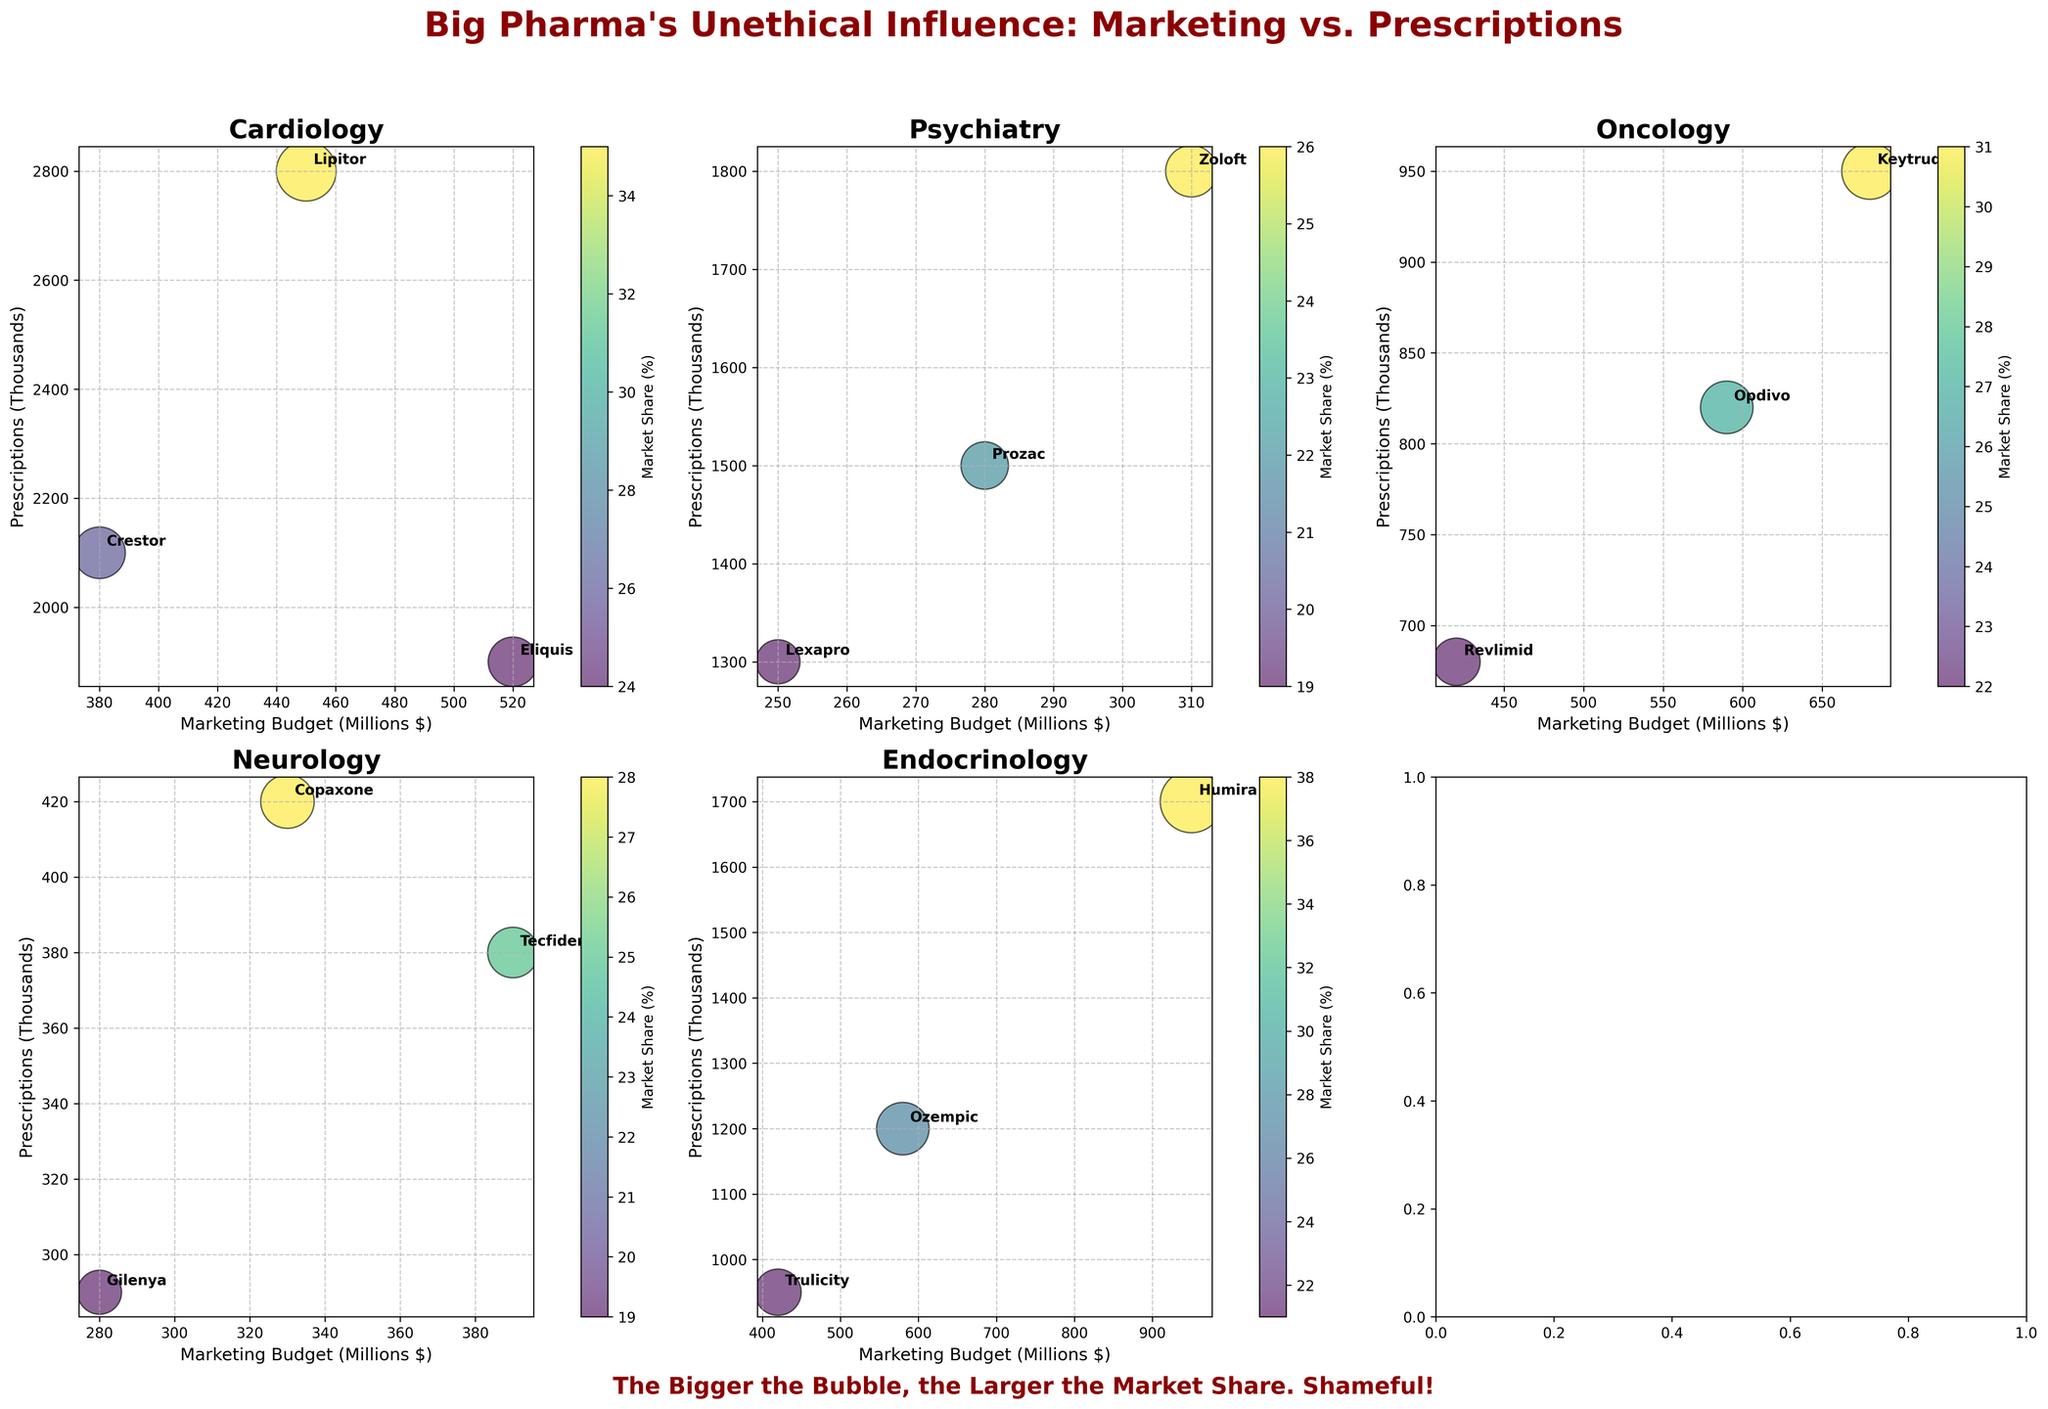What is the title of the figure? The figure's title is displayed prominently at the center top of the figure and is written in a large, bold font with a dark red color.
Answer: "Big Pharma's Unethical Influence: Marketing vs. Prescriptions" Which medical specialty has the highest marketing budget depicted in the figure? By looking at the subplots, the highest marketing budget is within the Endocrinology subplot, where Humira has a budget of 950 million dollars.
Answer: Endocrinology How does the size of the bubbles relate to the market share percentage? According to the plot, the size of each bubble is proportional to the market share percentage. The larger the bubble, the larger the market share the drug holds. This is indicated by the figure's annotation, which explains "The Bigger the Bubble, the Larger the Market Share. Shameful!".
Answer: Larger bubbles have a larger market share percentage Among the three oncology drugs shown, which one has the largest number of prescriptions and what marketing budget supports it? In the Oncology subplot, Keytruda has the largest number of prescriptions (950,000) and a marketing budget of 680 million dollars, which can be identified by checking the bubble with the highest position on the y-axis and corresponding annotations.
Answer: Keytruda, 680 million dollars Compare the prescriptions of Lipitor and Crestor within Cardiology. Which drug has more prescriptions and by how many thousands? Lipitor has 2800 thousand prescriptions and Crestor has 2100 thousand prescriptions. The difference in prescriptions is 2800 - 2100 = 700 thousand prescriptions.
Answer: Lipitor by 700 thousand What is the relationship between the marketing budget and the number of prescriptions for the three Neurology drugs? In Neurology, Copaxone, Tecfidera, and Gilenya each have corresponding marketing budgets and prescriptions. The relationship is as follows: Copaxone has a marketing budget of 330 million and 420 thousand prescriptions, Tecfidera has 390 million and 380 thousand prescriptions, and Gilenya has 280 million and 290 thousand prescriptions. There is no clear direct relationship in Neurology, as higher marketing budgets do not seem to consistently result in higher prescriptions.
Answer: No clear direct relationship For the Psychiatry specialty, rank the drugs by their market share from highest to lowest. In the Psychiatry subplot, the market shares are annotated and the size of bubbles indicates the following ranking from highest to lowest: Zoloft (26%), Prozac (22%), Lexapro (19%).
Answer: Zoloft > Prozac > Lexapro What common trend can be observed about drug marketing budgets and their corresponding market shares across different specialties? Generally, across different specialties, drugs with larger marketing budgets tend to have larger market shares, as indicated by the size of the bubbles. This suggests a positive correlation between marketing expenditure and market dominance.
Answer: Positive correlation between marketing budget and market share 